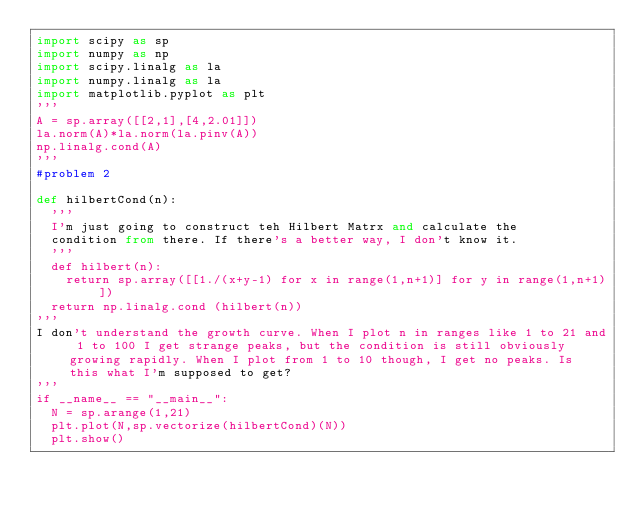Convert code to text. <code><loc_0><loc_0><loc_500><loc_500><_Python_>import scipy as sp
import numpy as np
import scipy.linalg as la
import numpy.linalg as la
import matplotlib.pyplot as plt
'''
A = sp.array([[2,1],[4,2.01]])
la.norm(A)*la.norm(la.pinv(A))
np.linalg.cond(A)
'''
#problem 2

def hilbertCond(n): 
	'''
	I'm just going to construct teh Hilbert Matrx and calculate the 
	condition from there. If there's a better way, I don't know it.
	'''
	def hilbert(n):
		return sp.array([[1./(x+y-1) for x in range(1,n+1)] for y in range(1,n+1)])
	return np.linalg.cond (hilbert(n))
'''	
I don't understand the growth curve. When I plot n in ranges like 1 to 21 and 1 to 100 I get strange peaks, but the condition is still obviously growing rapidly. When I plot from 1 to 10 though, I get no peaks. Is this what I'm supposed to get?
'''
if __name__ == "__main__":
	N = sp.arange(1,21)
	plt.plot(N,sp.vectorize(hilbertCond)(N))
	plt.show()

</code> 